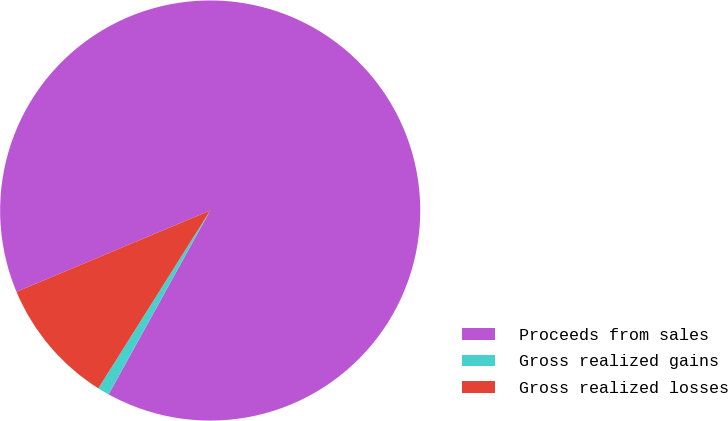Convert chart to OTSL. <chart><loc_0><loc_0><loc_500><loc_500><pie_chart><fcel>Proceeds from sales<fcel>Gross realized gains<fcel>Gross realized losses<nl><fcel>89.36%<fcel>0.9%<fcel>9.74%<nl></chart> 